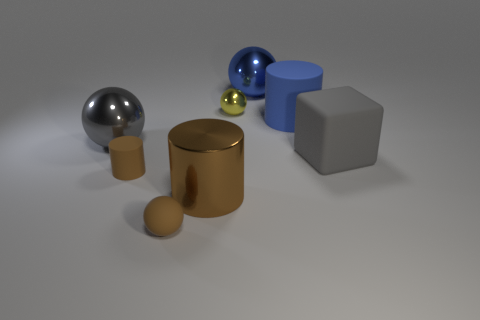Are there fewer tiny rubber cylinders than big green cubes?
Offer a terse response. No. Do the shiny thing that is in front of the gray metallic sphere and the tiny rubber ball have the same color?
Provide a short and direct response. Yes. The large cylinder to the right of the small thing that is behind the big ball that is in front of the big blue sphere is made of what material?
Give a very brief answer. Rubber. Are there any big blocks that have the same color as the shiny cylinder?
Give a very brief answer. No. Are there fewer big objects that are in front of the gray block than big cyan metallic balls?
Your answer should be compact. No. There is a gray object behind the rubber block; is its size the same as the blue matte thing?
Your response must be concise. Yes. What number of metal things are both behind the big cube and to the left of the yellow ball?
Ensure brevity in your answer.  1. There is a rubber cylinder to the left of the large blue ball that is behind the big gray rubber cube; how big is it?
Your response must be concise. Small. Are there fewer tiny cylinders in front of the shiny cylinder than metal objects in front of the blue shiny ball?
Offer a terse response. Yes. There is a metallic object left of the large brown metal object; does it have the same color as the large metal cylinder that is behind the rubber ball?
Your answer should be very brief. No. 